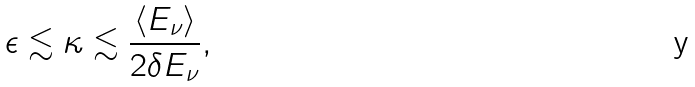Convert formula to latex. <formula><loc_0><loc_0><loc_500><loc_500>\epsilon \lesssim \kappa \lesssim \frac { \langle E _ { \nu } \rangle } { 2 \delta E _ { \nu } } ,</formula> 